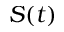<formula> <loc_0><loc_0><loc_500><loc_500>S ( t )</formula> 